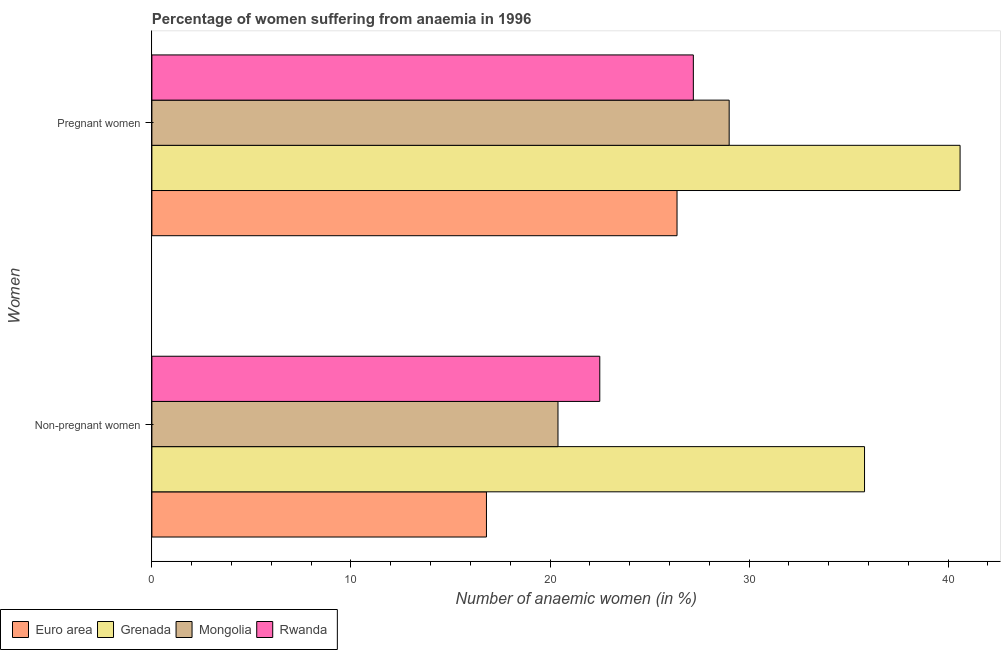Are the number of bars per tick equal to the number of legend labels?
Offer a terse response. Yes. How many bars are there on the 1st tick from the top?
Offer a terse response. 4. How many bars are there on the 2nd tick from the bottom?
Your answer should be very brief. 4. What is the label of the 1st group of bars from the top?
Keep it short and to the point. Pregnant women. What is the percentage of pregnant anaemic women in Grenada?
Your answer should be compact. 40.6. Across all countries, what is the maximum percentage of pregnant anaemic women?
Offer a very short reply. 40.6. Across all countries, what is the minimum percentage of pregnant anaemic women?
Make the answer very short. 26.38. In which country was the percentage of non-pregnant anaemic women maximum?
Ensure brevity in your answer.  Grenada. What is the total percentage of pregnant anaemic women in the graph?
Provide a succinct answer. 123.18. What is the difference between the percentage of non-pregnant anaemic women in Euro area and that in Rwanda?
Provide a short and direct response. -5.69. What is the difference between the percentage of non-pregnant anaemic women in Grenada and the percentage of pregnant anaemic women in Euro area?
Ensure brevity in your answer.  9.42. What is the average percentage of pregnant anaemic women per country?
Offer a very short reply. 30.8. What is the difference between the percentage of non-pregnant anaemic women and percentage of pregnant anaemic women in Euro area?
Offer a terse response. -9.57. What is the ratio of the percentage of pregnant anaemic women in Grenada to that in Mongolia?
Make the answer very short. 1.4. What does the 3rd bar from the top in Pregnant women represents?
Provide a short and direct response. Grenada. What does the 1st bar from the bottom in Non-pregnant women represents?
Make the answer very short. Euro area. Are all the bars in the graph horizontal?
Ensure brevity in your answer.  Yes. What is the difference between two consecutive major ticks on the X-axis?
Make the answer very short. 10. Does the graph contain grids?
Make the answer very short. No. Where does the legend appear in the graph?
Keep it short and to the point. Bottom left. How are the legend labels stacked?
Keep it short and to the point. Horizontal. What is the title of the graph?
Offer a terse response. Percentage of women suffering from anaemia in 1996. What is the label or title of the X-axis?
Provide a succinct answer. Number of anaemic women (in %). What is the label or title of the Y-axis?
Your answer should be very brief. Women. What is the Number of anaemic women (in %) of Euro area in Non-pregnant women?
Ensure brevity in your answer.  16.81. What is the Number of anaemic women (in %) of Grenada in Non-pregnant women?
Your response must be concise. 35.8. What is the Number of anaemic women (in %) of Mongolia in Non-pregnant women?
Make the answer very short. 20.4. What is the Number of anaemic women (in %) in Rwanda in Non-pregnant women?
Give a very brief answer. 22.5. What is the Number of anaemic women (in %) in Euro area in Pregnant women?
Keep it short and to the point. 26.38. What is the Number of anaemic women (in %) in Grenada in Pregnant women?
Your answer should be very brief. 40.6. What is the Number of anaemic women (in %) in Rwanda in Pregnant women?
Make the answer very short. 27.2. Across all Women, what is the maximum Number of anaemic women (in %) of Euro area?
Your response must be concise. 26.38. Across all Women, what is the maximum Number of anaemic women (in %) in Grenada?
Offer a very short reply. 40.6. Across all Women, what is the maximum Number of anaemic women (in %) of Mongolia?
Provide a succinct answer. 29. Across all Women, what is the maximum Number of anaemic women (in %) of Rwanda?
Provide a succinct answer. 27.2. Across all Women, what is the minimum Number of anaemic women (in %) of Euro area?
Keep it short and to the point. 16.81. Across all Women, what is the minimum Number of anaemic women (in %) in Grenada?
Your response must be concise. 35.8. Across all Women, what is the minimum Number of anaemic women (in %) in Mongolia?
Give a very brief answer. 20.4. Across all Women, what is the minimum Number of anaemic women (in %) in Rwanda?
Offer a terse response. 22.5. What is the total Number of anaemic women (in %) of Euro area in the graph?
Your answer should be compact. 43.19. What is the total Number of anaemic women (in %) of Grenada in the graph?
Your answer should be compact. 76.4. What is the total Number of anaemic women (in %) in Mongolia in the graph?
Provide a succinct answer. 49.4. What is the total Number of anaemic women (in %) in Rwanda in the graph?
Your answer should be very brief. 49.7. What is the difference between the Number of anaemic women (in %) in Euro area in Non-pregnant women and that in Pregnant women?
Keep it short and to the point. -9.57. What is the difference between the Number of anaemic women (in %) in Mongolia in Non-pregnant women and that in Pregnant women?
Provide a succinct answer. -8.6. What is the difference between the Number of anaemic women (in %) of Euro area in Non-pregnant women and the Number of anaemic women (in %) of Grenada in Pregnant women?
Ensure brevity in your answer.  -23.79. What is the difference between the Number of anaemic women (in %) in Euro area in Non-pregnant women and the Number of anaemic women (in %) in Mongolia in Pregnant women?
Ensure brevity in your answer.  -12.19. What is the difference between the Number of anaemic women (in %) of Euro area in Non-pregnant women and the Number of anaemic women (in %) of Rwanda in Pregnant women?
Provide a succinct answer. -10.39. What is the difference between the Number of anaemic women (in %) in Grenada in Non-pregnant women and the Number of anaemic women (in %) in Mongolia in Pregnant women?
Your response must be concise. 6.8. What is the average Number of anaemic women (in %) in Euro area per Women?
Ensure brevity in your answer.  21.59. What is the average Number of anaemic women (in %) in Grenada per Women?
Your response must be concise. 38.2. What is the average Number of anaemic women (in %) in Mongolia per Women?
Offer a very short reply. 24.7. What is the average Number of anaemic women (in %) in Rwanda per Women?
Make the answer very short. 24.85. What is the difference between the Number of anaemic women (in %) of Euro area and Number of anaemic women (in %) of Grenada in Non-pregnant women?
Your response must be concise. -18.99. What is the difference between the Number of anaemic women (in %) of Euro area and Number of anaemic women (in %) of Mongolia in Non-pregnant women?
Keep it short and to the point. -3.59. What is the difference between the Number of anaemic women (in %) of Euro area and Number of anaemic women (in %) of Rwanda in Non-pregnant women?
Make the answer very short. -5.69. What is the difference between the Number of anaemic women (in %) of Grenada and Number of anaemic women (in %) of Rwanda in Non-pregnant women?
Offer a terse response. 13.3. What is the difference between the Number of anaemic women (in %) in Euro area and Number of anaemic women (in %) in Grenada in Pregnant women?
Provide a short and direct response. -14.22. What is the difference between the Number of anaemic women (in %) in Euro area and Number of anaemic women (in %) in Mongolia in Pregnant women?
Ensure brevity in your answer.  -2.62. What is the difference between the Number of anaemic women (in %) of Euro area and Number of anaemic women (in %) of Rwanda in Pregnant women?
Offer a very short reply. -0.82. What is the ratio of the Number of anaemic women (in %) of Euro area in Non-pregnant women to that in Pregnant women?
Provide a succinct answer. 0.64. What is the ratio of the Number of anaemic women (in %) of Grenada in Non-pregnant women to that in Pregnant women?
Provide a succinct answer. 0.88. What is the ratio of the Number of anaemic women (in %) in Mongolia in Non-pregnant women to that in Pregnant women?
Offer a terse response. 0.7. What is the ratio of the Number of anaemic women (in %) of Rwanda in Non-pregnant women to that in Pregnant women?
Your answer should be compact. 0.83. What is the difference between the highest and the second highest Number of anaemic women (in %) of Euro area?
Your response must be concise. 9.57. What is the difference between the highest and the second highest Number of anaemic women (in %) of Mongolia?
Make the answer very short. 8.6. What is the difference between the highest and the second highest Number of anaemic women (in %) in Rwanda?
Offer a terse response. 4.7. What is the difference between the highest and the lowest Number of anaemic women (in %) in Euro area?
Make the answer very short. 9.57. What is the difference between the highest and the lowest Number of anaemic women (in %) of Grenada?
Your answer should be compact. 4.8. What is the difference between the highest and the lowest Number of anaemic women (in %) of Mongolia?
Ensure brevity in your answer.  8.6. What is the difference between the highest and the lowest Number of anaemic women (in %) in Rwanda?
Provide a succinct answer. 4.7. 